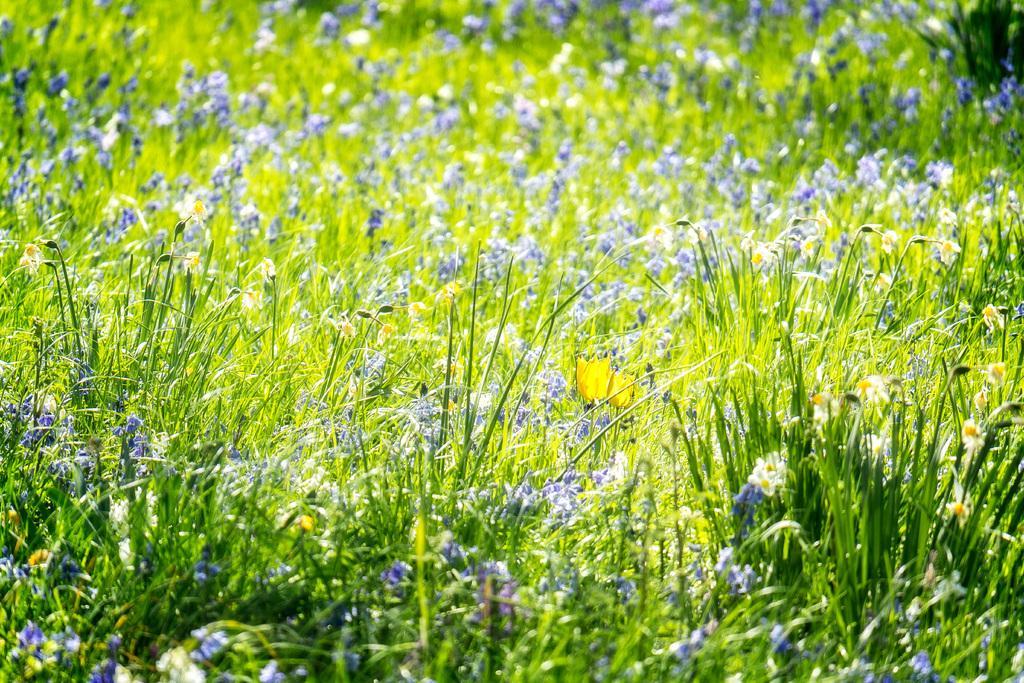In one or two sentences, can you explain what this image depicts? In this picture we can see few plants and flowers. 